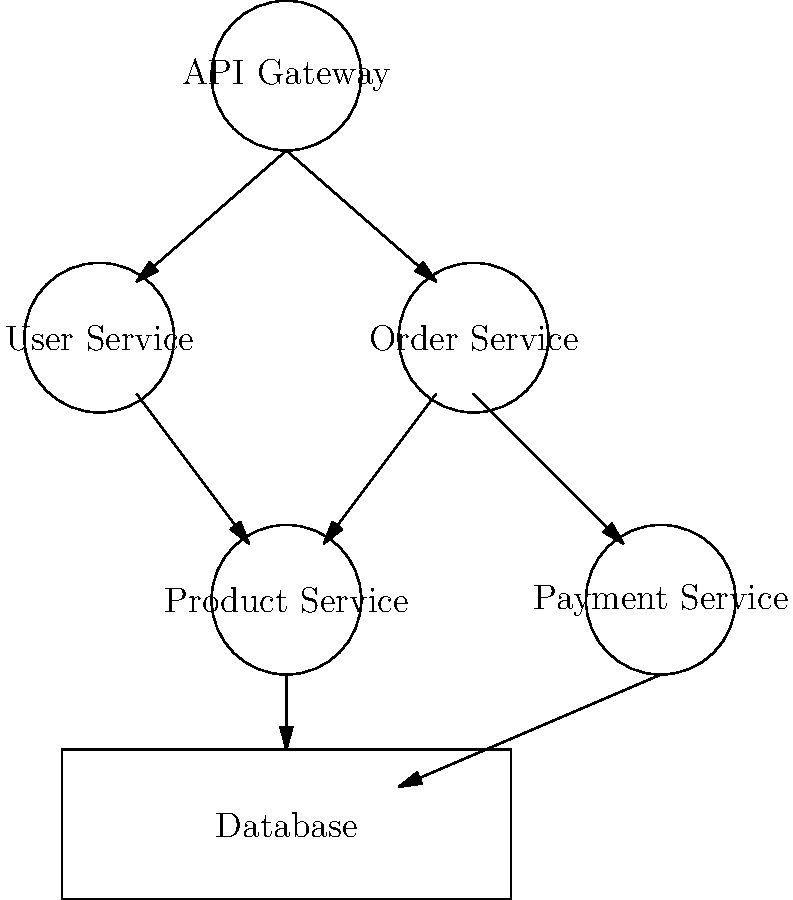Analyze the given microservices architecture diagram. Which service is likely to be the most critical in terms of system availability and performance, and why? To determine the most critical service in terms of system availability and performance, we need to analyze the diagram and consider the following steps:

1. Identify the entry point: The API Gateway is the entry point for all requests.

2. Analyze dependencies:
   - User Service and Order Service depend directly on the API Gateway.
   - Product Service is connected to both User Service and Order Service.
   - Payment Service is connected to the Order Service.
   - All services are connected to the Database.

3. Consider the service roles:
   - API Gateway: Routes requests to appropriate services.
   - User Service: Likely handles authentication and user-related operations.
   - Order Service: Manages order processing and interacts with Product and Payment services.
   - Product Service: Provides product information.
   - Payment Service: Handles payment transactions.

4. Evaluate criticality:
   - The API Gateway is the single entry point for all requests, making it a potential bottleneck.
   - If the API Gateway fails, no requests can be processed, affecting the entire system.
   - Other services have more localized impacts if they fail.

5. Performance considerations:
   - The API Gateway needs to handle all incoming traffic efficiently.
   - Poor performance in the API Gateway would affect all subsequent operations.

Given these factors, the API Gateway is likely to be the most critical service in terms of system availability and performance. Its failure would render the entire system unavailable, and its performance directly impacts the responsiveness of all other services.
Answer: API Gateway 